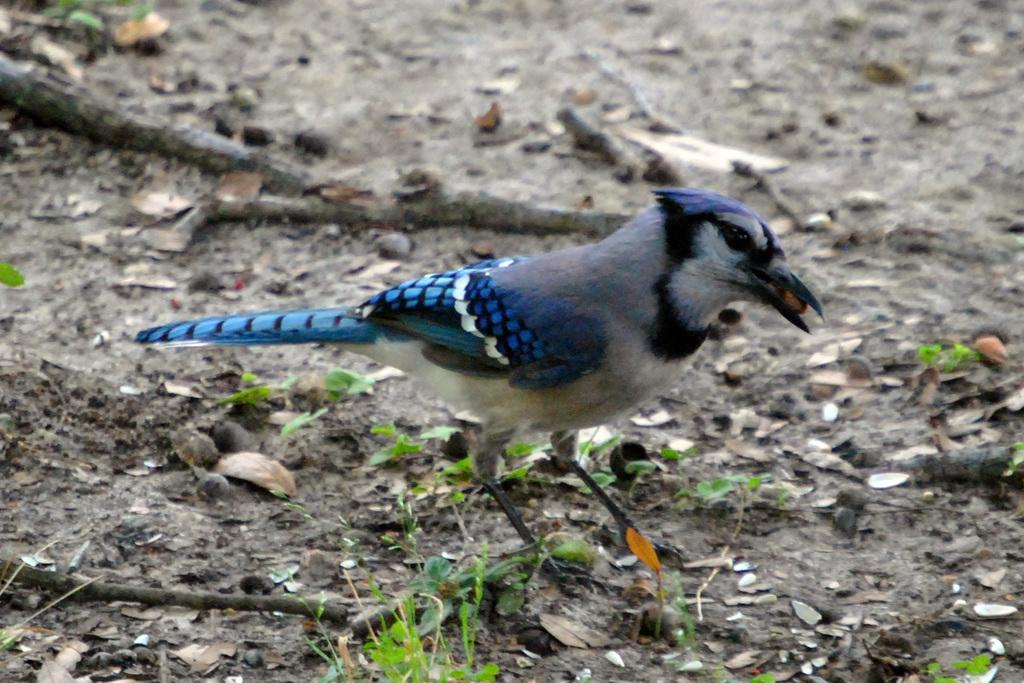What type of animal can be seen in the image? There is a bird in the image. What other living organisms are present in the image? There are plants in the image. What can be found on the ground in the image? There are sticks on the ground in the image. What type of cup is being used by the bird in the image? There is no cup present in the image, as it features a bird and plants with sticks on the ground. 